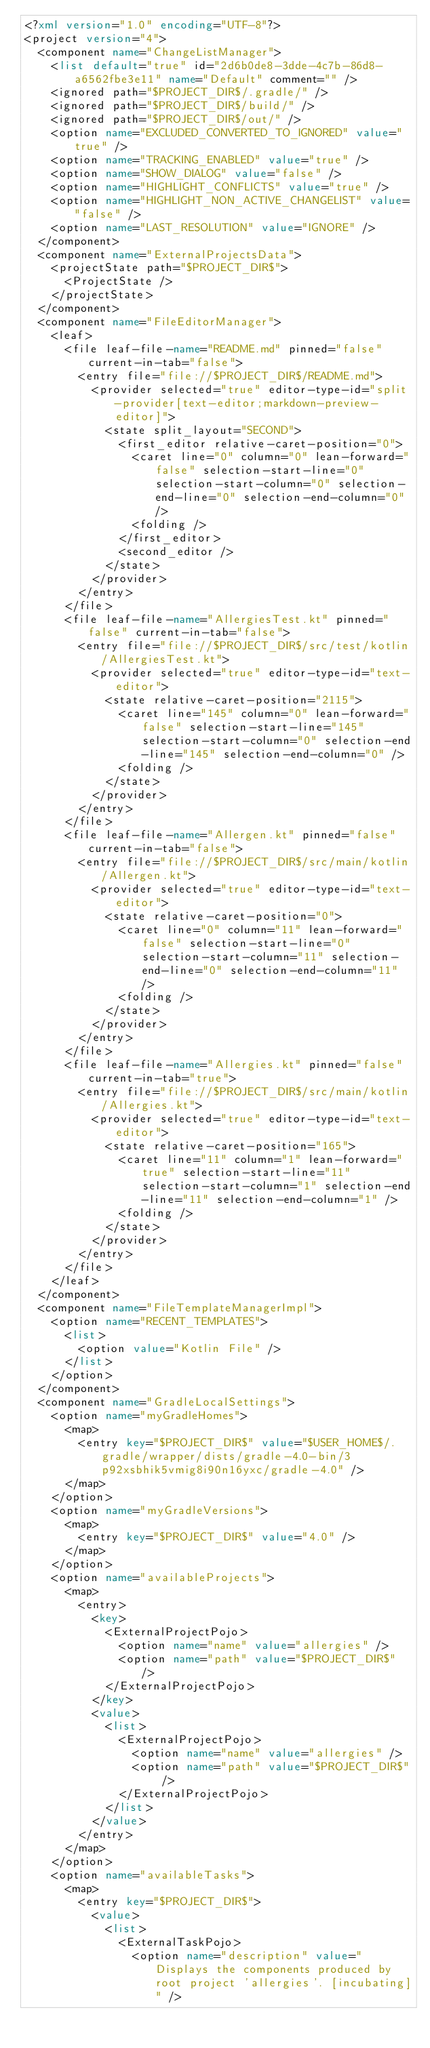Convert code to text. <code><loc_0><loc_0><loc_500><loc_500><_XML_><?xml version="1.0" encoding="UTF-8"?>
<project version="4">
  <component name="ChangeListManager">
    <list default="true" id="2d6b0de8-3dde-4c7b-86d8-a6562fbe3e11" name="Default" comment="" />
    <ignored path="$PROJECT_DIR$/.gradle/" />
    <ignored path="$PROJECT_DIR$/build/" />
    <ignored path="$PROJECT_DIR$/out/" />
    <option name="EXCLUDED_CONVERTED_TO_IGNORED" value="true" />
    <option name="TRACKING_ENABLED" value="true" />
    <option name="SHOW_DIALOG" value="false" />
    <option name="HIGHLIGHT_CONFLICTS" value="true" />
    <option name="HIGHLIGHT_NON_ACTIVE_CHANGELIST" value="false" />
    <option name="LAST_RESOLUTION" value="IGNORE" />
  </component>
  <component name="ExternalProjectsData">
    <projectState path="$PROJECT_DIR$">
      <ProjectState />
    </projectState>
  </component>
  <component name="FileEditorManager">
    <leaf>
      <file leaf-file-name="README.md" pinned="false" current-in-tab="false">
        <entry file="file://$PROJECT_DIR$/README.md">
          <provider selected="true" editor-type-id="split-provider[text-editor;markdown-preview-editor]">
            <state split_layout="SECOND">
              <first_editor relative-caret-position="0">
                <caret line="0" column="0" lean-forward="false" selection-start-line="0" selection-start-column="0" selection-end-line="0" selection-end-column="0" />
                <folding />
              </first_editor>
              <second_editor />
            </state>
          </provider>
        </entry>
      </file>
      <file leaf-file-name="AllergiesTest.kt" pinned="false" current-in-tab="false">
        <entry file="file://$PROJECT_DIR$/src/test/kotlin/AllergiesTest.kt">
          <provider selected="true" editor-type-id="text-editor">
            <state relative-caret-position="2115">
              <caret line="145" column="0" lean-forward="false" selection-start-line="145" selection-start-column="0" selection-end-line="145" selection-end-column="0" />
              <folding />
            </state>
          </provider>
        </entry>
      </file>
      <file leaf-file-name="Allergen.kt" pinned="false" current-in-tab="false">
        <entry file="file://$PROJECT_DIR$/src/main/kotlin/Allergen.kt">
          <provider selected="true" editor-type-id="text-editor">
            <state relative-caret-position="0">
              <caret line="0" column="11" lean-forward="false" selection-start-line="0" selection-start-column="11" selection-end-line="0" selection-end-column="11" />
              <folding />
            </state>
          </provider>
        </entry>
      </file>
      <file leaf-file-name="Allergies.kt" pinned="false" current-in-tab="true">
        <entry file="file://$PROJECT_DIR$/src/main/kotlin/Allergies.kt">
          <provider selected="true" editor-type-id="text-editor">
            <state relative-caret-position="165">
              <caret line="11" column="1" lean-forward="true" selection-start-line="11" selection-start-column="1" selection-end-line="11" selection-end-column="1" />
              <folding />
            </state>
          </provider>
        </entry>
      </file>
    </leaf>
  </component>
  <component name="FileTemplateManagerImpl">
    <option name="RECENT_TEMPLATES">
      <list>
        <option value="Kotlin File" />
      </list>
    </option>
  </component>
  <component name="GradleLocalSettings">
    <option name="myGradleHomes">
      <map>
        <entry key="$PROJECT_DIR$" value="$USER_HOME$/.gradle/wrapper/dists/gradle-4.0-bin/3p92xsbhik5vmig8i90n16yxc/gradle-4.0" />
      </map>
    </option>
    <option name="myGradleVersions">
      <map>
        <entry key="$PROJECT_DIR$" value="4.0" />
      </map>
    </option>
    <option name="availableProjects">
      <map>
        <entry>
          <key>
            <ExternalProjectPojo>
              <option name="name" value="allergies" />
              <option name="path" value="$PROJECT_DIR$" />
            </ExternalProjectPojo>
          </key>
          <value>
            <list>
              <ExternalProjectPojo>
                <option name="name" value="allergies" />
                <option name="path" value="$PROJECT_DIR$" />
              </ExternalProjectPojo>
            </list>
          </value>
        </entry>
      </map>
    </option>
    <option name="availableTasks">
      <map>
        <entry key="$PROJECT_DIR$">
          <value>
            <list>
              <ExternalTaskPojo>
                <option name="description" value="Displays the components produced by root project 'allergies'. [incubating]" /></code> 